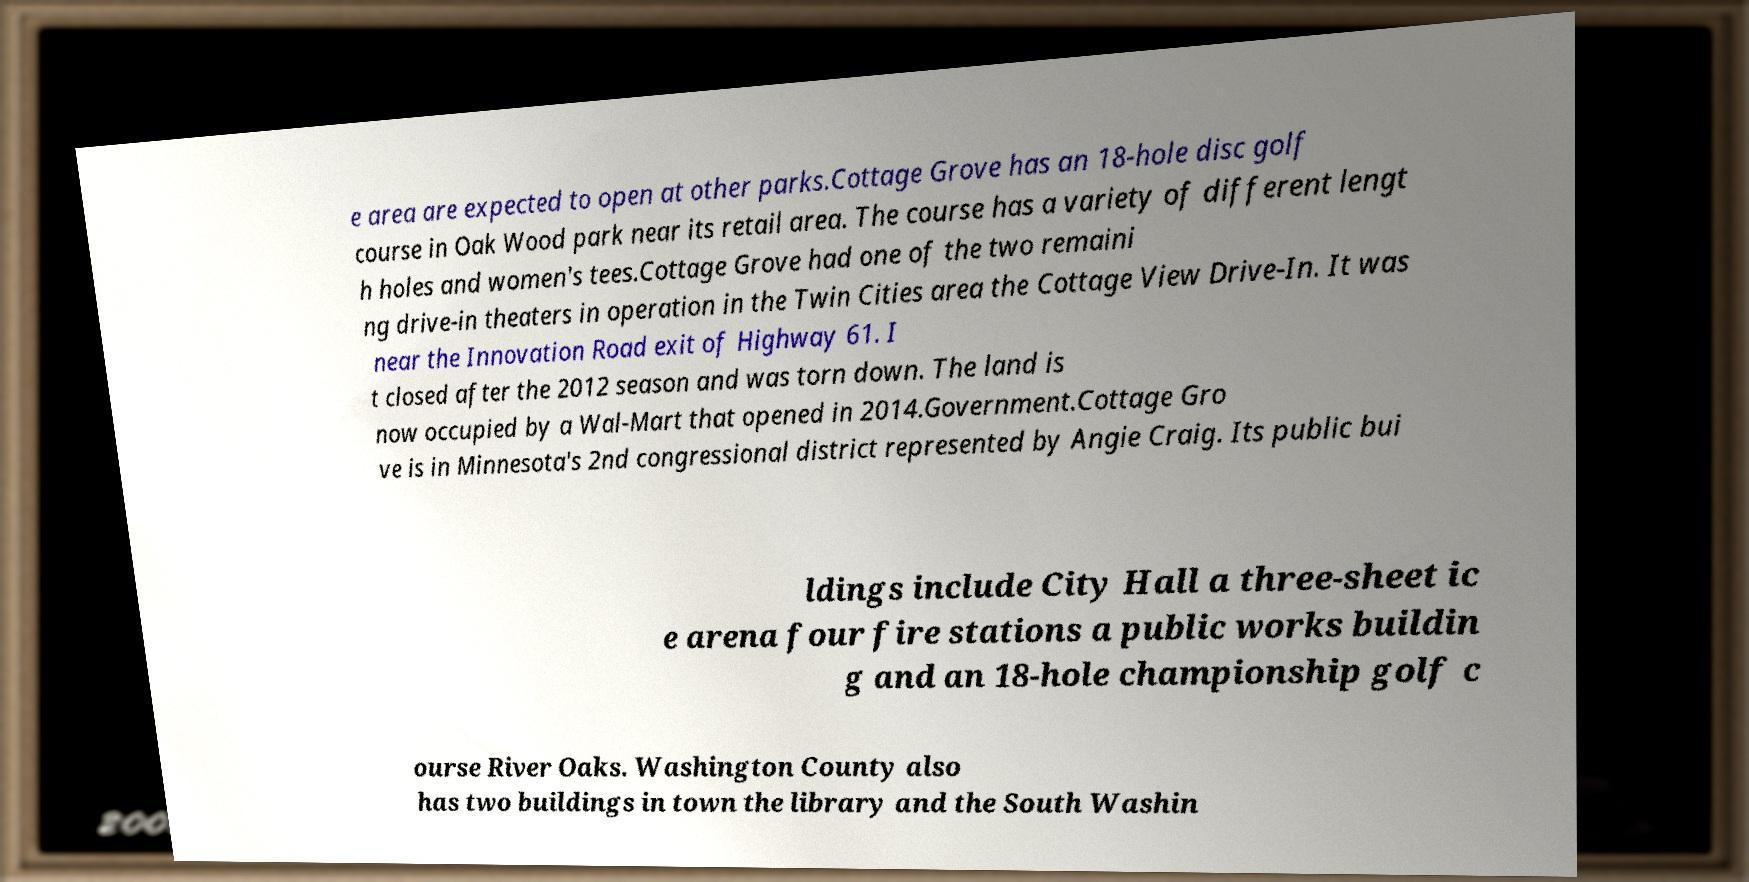Could you extract and type out the text from this image? e area are expected to open at other parks.Cottage Grove has an 18-hole disc golf course in Oak Wood park near its retail area. The course has a variety of different lengt h holes and women's tees.Cottage Grove had one of the two remaini ng drive-in theaters in operation in the Twin Cities area the Cottage View Drive-In. It was near the Innovation Road exit of Highway 61. I t closed after the 2012 season and was torn down. The land is now occupied by a Wal-Mart that opened in 2014.Government.Cottage Gro ve is in Minnesota's 2nd congressional district represented by Angie Craig. Its public bui ldings include City Hall a three-sheet ic e arena four fire stations a public works buildin g and an 18-hole championship golf c ourse River Oaks. Washington County also has two buildings in town the library and the South Washin 